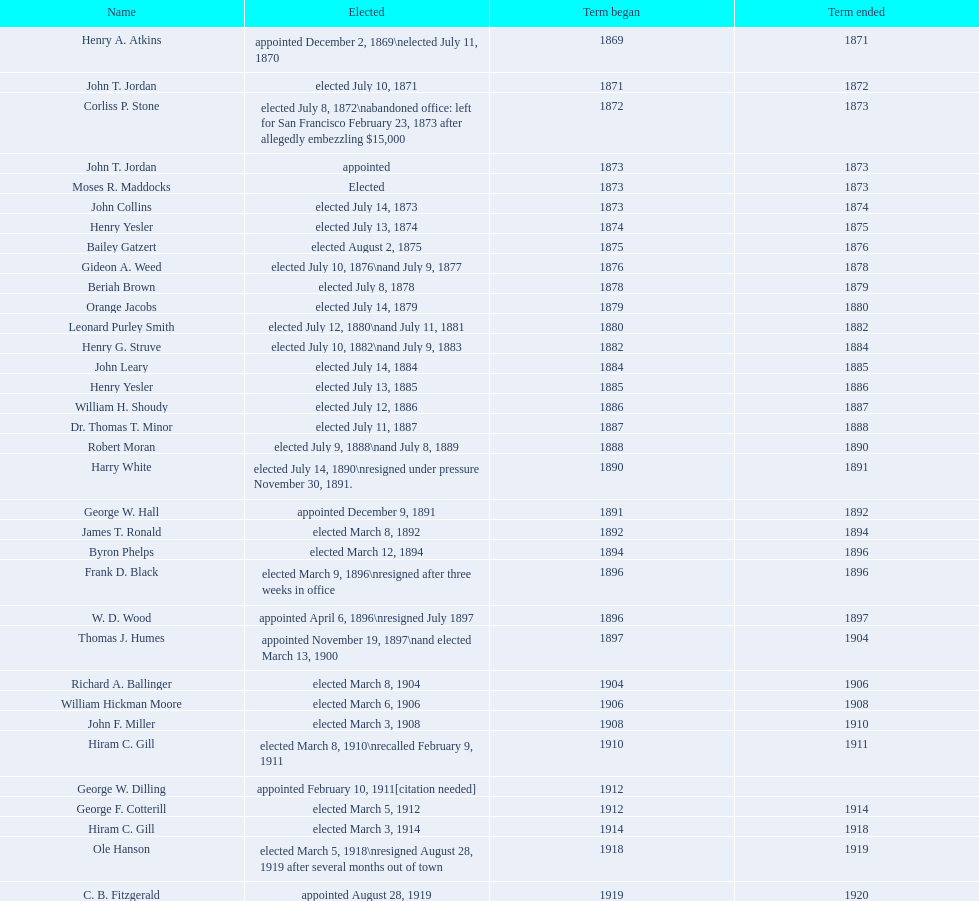Can you give me this table as a dict? {'header': ['Name', 'Elected', 'Term began', 'Term ended'], 'rows': [['Henry A. Atkins', 'appointed December 2, 1869\\nelected July 11, 1870', '1869', '1871'], ['John T. Jordan', 'elected July 10, 1871', '1871', '1872'], ['Corliss P. Stone', 'elected July 8, 1872\\nabandoned office: left for San Francisco February 23, 1873 after allegedly embezzling $15,000', '1872', '1873'], ['John T. Jordan', 'appointed', '1873', '1873'], ['Moses R. Maddocks', 'Elected', '1873', '1873'], ['John Collins', 'elected July 14, 1873', '1873', '1874'], ['Henry Yesler', 'elected July 13, 1874', '1874', '1875'], ['Bailey Gatzert', 'elected August 2, 1875', '1875', '1876'], ['Gideon A. Weed', 'elected July 10, 1876\\nand July 9, 1877', '1876', '1878'], ['Beriah Brown', 'elected July 8, 1878', '1878', '1879'], ['Orange Jacobs', 'elected July 14, 1879', '1879', '1880'], ['Leonard Purley Smith', 'elected July 12, 1880\\nand July 11, 1881', '1880', '1882'], ['Henry G. Struve', 'elected July 10, 1882\\nand July 9, 1883', '1882', '1884'], ['John Leary', 'elected July 14, 1884', '1884', '1885'], ['Henry Yesler', 'elected July 13, 1885', '1885', '1886'], ['William H. Shoudy', 'elected July 12, 1886', '1886', '1887'], ['Dr. Thomas T. Minor', 'elected July 11, 1887', '1887', '1888'], ['Robert Moran', 'elected July 9, 1888\\nand July 8, 1889', '1888', '1890'], ['Harry White', 'elected July 14, 1890\\nresigned under pressure November 30, 1891.', '1890', '1891'], ['George W. Hall', 'appointed December 9, 1891', '1891', '1892'], ['James T. Ronald', 'elected March 8, 1892', '1892', '1894'], ['Byron Phelps', 'elected March 12, 1894', '1894', '1896'], ['Frank D. Black', 'elected March 9, 1896\\nresigned after three weeks in office', '1896', '1896'], ['W. D. Wood', 'appointed April 6, 1896\\nresigned July 1897', '1896', '1897'], ['Thomas J. Humes', 'appointed November 19, 1897\\nand elected March 13, 1900', '1897', '1904'], ['Richard A. Ballinger', 'elected March 8, 1904', '1904', '1906'], ['William Hickman Moore', 'elected March 6, 1906', '1906', '1908'], ['John F. Miller', 'elected March 3, 1908', '1908', '1910'], ['Hiram C. Gill', 'elected March 8, 1910\\nrecalled February 9, 1911', '1910', '1911'], ['George W. Dilling', 'appointed February 10, 1911[citation needed]', '1912', ''], ['George F. Cotterill', 'elected March 5, 1912', '1912', '1914'], ['Hiram C. Gill', 'elected March 3, 1914', '1914', '1918'], ['Ole Hanson', 'elected March 5, 1918\\nresigned August 28, 1919 after several months out of town', '1918', '1919'], ['C. B. Fitzgerald', 'appointed August 28, 1919', '1919', '1920'], ['Hugh M. Caldwell', 'elected March 2, 1920', '1920', '1922'], ['Edwin J. Brown', 'elected May 2, 1922\\nand March 4, 1924', '1922', '1926'], ['Bertha Knight Landes', 'elected March 9, 1926', '1926', '1928'], ['Frank E. Edwards', 'elected March 6, 1928\\nand March 4, 1930\\nrecalled July 13, 1931', '1928', '1931'], ['Robert H. Harlin', 'appointed July 14, 1931', '1931', '1932'], ['John F. Dore', 'elected March 8, 1932', '1932', '1934'], ['Charles L. Smith', 'elected March 6, 1934', '1934', '1936'], ['John F. Dore', 'elected March 3, 1936\\nbecame gravely ill and was relieved of office April 13, 1938, already a lame duck after the 1938 election. He died five days later.', '1936', '1938'], ['Arthur B. Langlie', "elected March 8, 1938\\nappointed to take office early, April 27, 1938, after Dore's death.\\nelected March 5, 1940\\nresigned January 11, 1941, to become Governor of Washington", '1938', '1941'], ['John E. Carroll', 'appointed January 27, 1941', '1941', '1941'], ['Earl Millikin', 'elected March 4, 1941', '1941', '1942'], ['William F. Devin', 'elected March 3, 1942, March 7, 1944, March 5, 1946, and March 2, 1948', '1942', '1952'], ['Allan Pomeroy', 'elected March 4, 1952', '1952', '1956'], ['Gordon S. Clinton', 'elected March 6, 1956\\nand March 8, 1960', '1956', '1964'], ["James d'Orma Braman", 'elected March 10, 1964\\nresigned March 23, 1969, to accept an appointment as an Assistant Secretary in the Department of Transportation in the Nixon administration.', '1964', '1969'], ['Floyd C. Miller', 'appointed March 23, 1969', '1969', '1969'], ['Wesley C. Uhlman', 'elected November 4, 1969\\nand November 6, 1973\\nsurvived recall attempt on July 1, 1975', 'December 1, 1969', 'January 1, 1978'], ['Charles Royer', 'elected November 8, 1977, November 3, 1981, and November 5, 1985', 'January 1, 1978', 'January 1, 1990'], ['Norman B. Rice', 'elected November 7, 1989', 'January 1, 1990', 'January 1, 1998'], ['Paul Schell', 'elected November 4, 1997', 'January 1, 1998', 'January 1, 2002'], ['Gregory J. Nickels', 'elected November 6, 2001\\nand November 8, 2005', 'January 1, 2002', 'January 1, 2010'], ['Michael McGinn', 'elected November 3, 2009', 'January 1, 2010', 'January 1, 2014'], ['Ed Murray', 'elected November 5, 2013', 'January 1, 2014', 'present']]} Who was the sole individual chosen in 1871? John T. Jordan. 